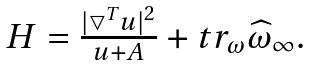Convert formula to latex. <formula><loc_0><loc_0><loc_500><loc_500>\begin{array} [ c ] { c } H = \frac { | \bigtriangledown ^ { T } u | ^ { 2 } } { u + A } + t r _ { \omega } \widehat { \omega } _ { \infty } . \end{array}</formula> 